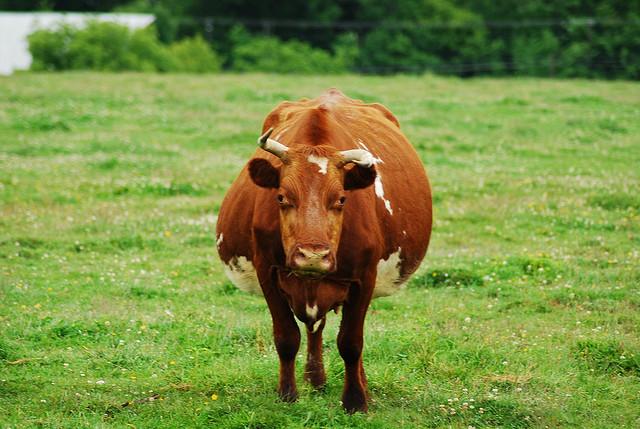Does this animal have even horns?
Be succinct. No. Does this animal produces dairy products?
Short answer required. Yes. What kind of landform is the animal in?
Quick response, please. Field. 